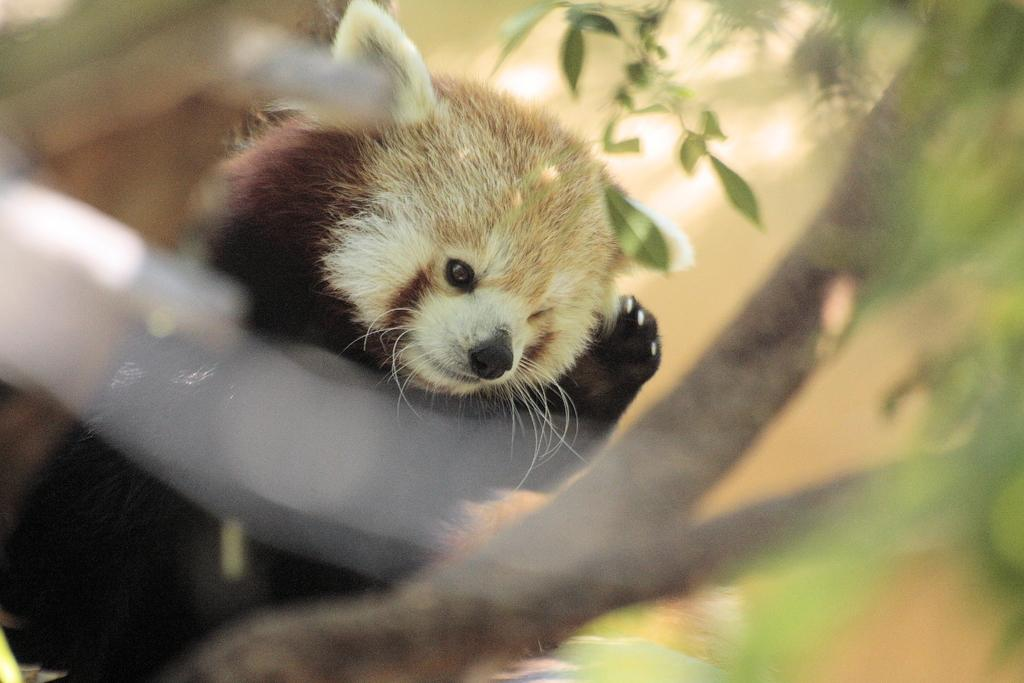What is the overall quality of the image? The image has a blurry view. What type of animal can be seen in the image? There is a red panda in the image. What natural elements are visible in the image? Tree branches and leaves are present in the image. What type of rose is being held by the red panda in the image? There is no rose present in the image; it features a red panda and natural elements like tree branches and leaves. 